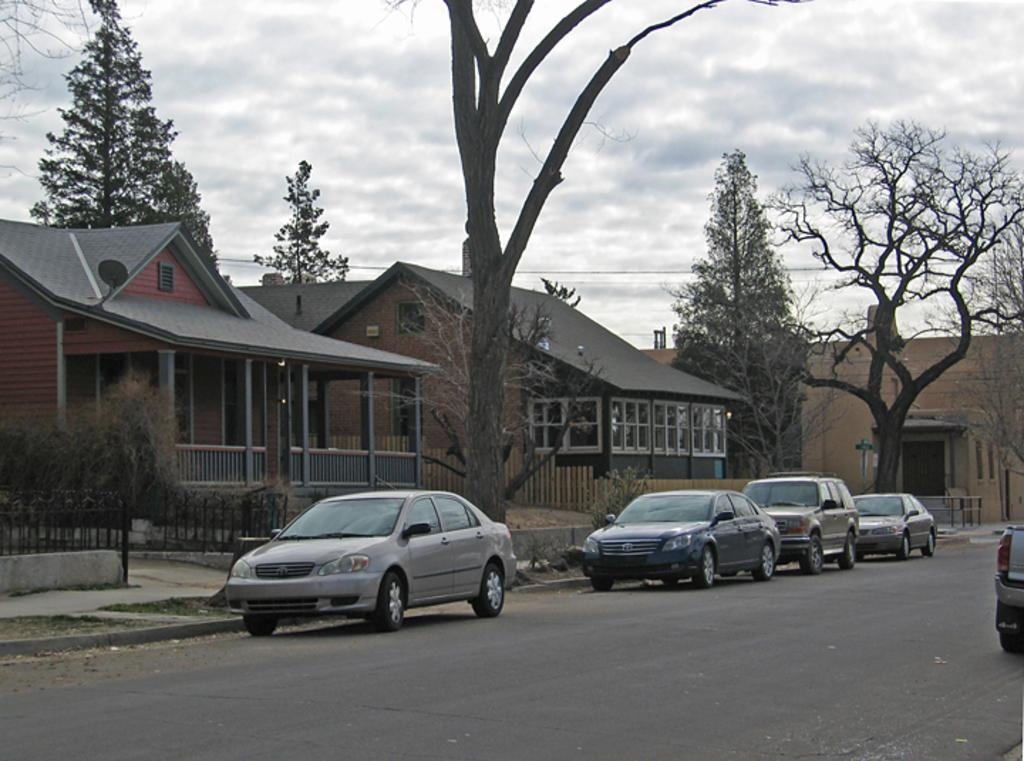What can be seen on the road in the image? There are many vehicles on the road in the image. What type of structures can be seen in the image? There are houses visible in the image. What natural elements are present in the image? Trees are present in the image. What type of barrier can be seen in the image? There is a fence in the image. What type of vegetation is visible in the image? A plant is visible in the image. What man-made structures are present in the image? Electric wires are present in the image. What is the weather like in the image? The sky is cloudy in the image. What type of pump is visible in the image? There is no pump present in the image. What type of sheet is covering the trees in the image? There is no sheet covering the trees in the image; the trees are visible without any coverings. 